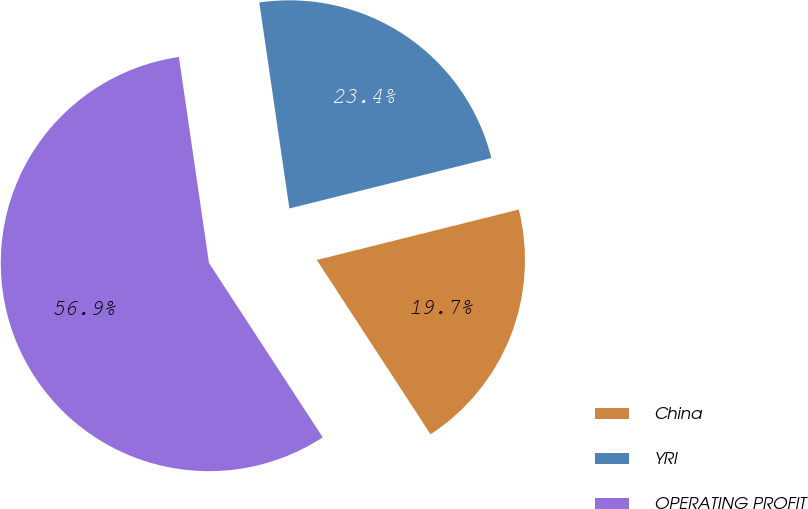Convert chart. <chart><loc_0><loc_0><loc_500><loc_500><pie_chart><fcel>China<fcel>YRI<fcel>OPERATING PROFIT<nl><fcel>19.69%<fcel>23.41%<fcel>56.89%<nl></chart> 